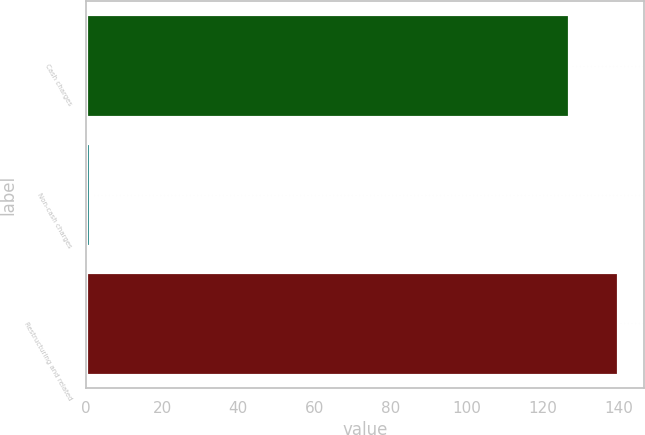Convert chart to OTSL. <chart><loc_0><loc_0><loc_500><loc_500><bar_chart><fcel>Cash charges<fcel>Non-cash charges<fcel>Restructuring and related<nl><fcel>127<fcel>1<fcel>139.7<nl></chart> 